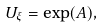<formula> <loc_0><loc_0><loc_500><loc_500>U _ { \xi } = \exp ( A ) ,</formula> 